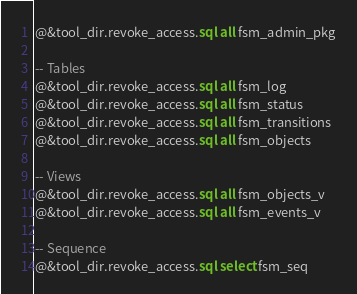<code> <loc_0><loc_0><loc_500><loc_500><_SQL_>@&tool_dir.revoke_access.sql all fsm_admin_pkg

-- Tables
@&tool_dir.revoke_access.sql all fsm_log
@&tool_dir.revoke_access.sql all fsm_status
@&tool_dir.revoke_access.sql all fsm_transitions
@&tool_dir.revoke_access.sql all fsm_objects

-- Views
@&tool_dir.revoke_access.sql all fsm_objects_v
@&tool_dir.revoke_access.sql all fsm_events_v

-- Sequence
@&tool_dir.revoke_access.sql select fsm_seq
</code> 